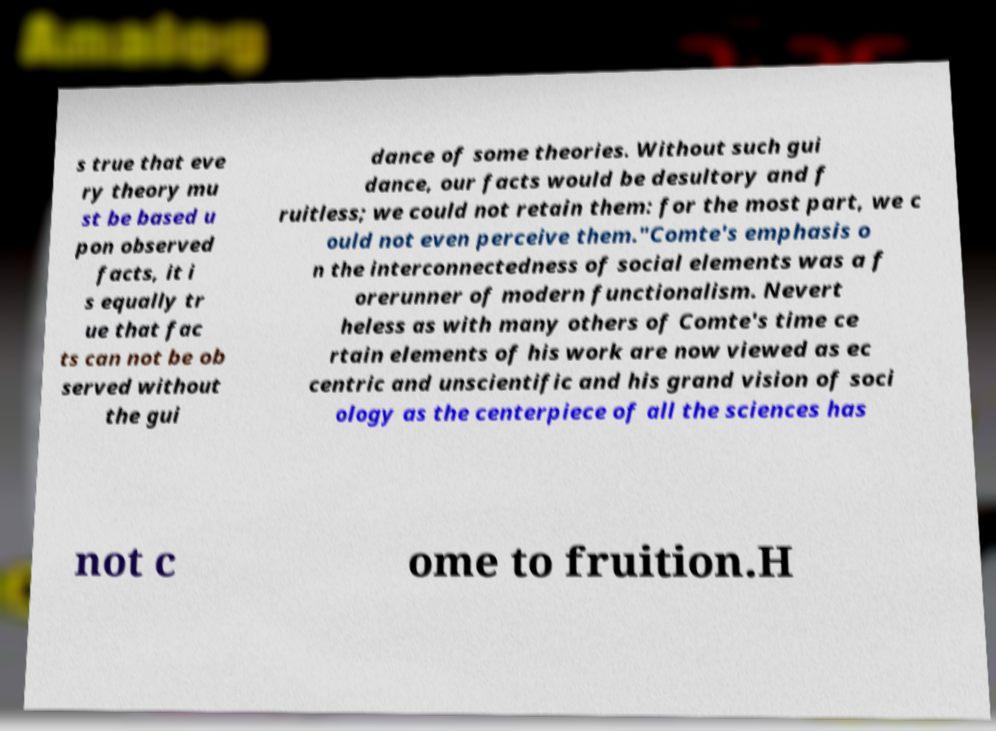Can you read and provide the text displayed in the image?This photo seems to have some interesting text. Can you extract and type it out for me? s true that eve ry theory mu st be based u pon observed facts, it i s equally tr ue that fac ts can not be ob served without the gui dance of some theories. Without such gui dance, our facts would be desultory and f ruitless; we could not retain them: for the most part, we c ould not even perceive them."Comte's emphasis o n the interconnectedness of social elements was a f orerunner of modern functionalism. Nevert heless as with many others of Comte's time ce rtain elements of his work are now viewed as ec centric and unscientific and his grand vision of soci ology as the centerpiece of all the sciences has not c ome to fruition.H 